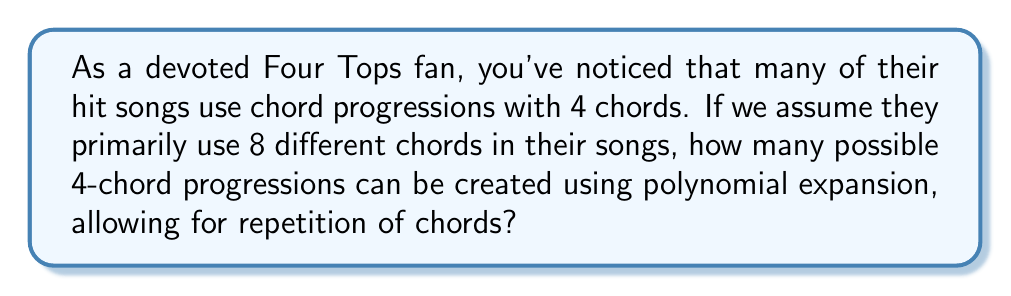Help me with this question. To solve this problem, we need to use the concept of polynomial expansion and combinations with repetition. Here's a step-by-step explanation:

1. We have 8 different chords to choose from, and we're creating a progression of 4 chords.

2. This scenario is equivalent to selecting 4 items from a set of 8, with replacement (as chords can be repeated).

3. In polynomial expansion, this is represented by the term $x^4$ in the expansion of $(x_1 + x_2 + ... + x_8)^4$.

4. The number of terms in this expansion is equal to the number of ways to choose 4 items from 8 with repetition allowed.

5. The formula for this is:
   $$\binom{n+r-1}{r} = \binom{8+4-1}{4} = \binom{11}{4}$$
   where $n=8$ (number of chord options) and $r=4$ (length of progression)

6. We can calculate this using the combination formula:
   $$\binom{11}{4} = \frac{11!}{4!(11-4)!} = \frac{11!}{4!7!}$$

7. Expanding this:
   $$\frac{11 \times 10 \times 9 \times 8}{4 \times 3 \times 2 \times 1} = 330$$

Therefore, there are 330 possible 4-chord progressions using 8 different chords, allowing for repetition.
Answer: 330 possible chord progressions 